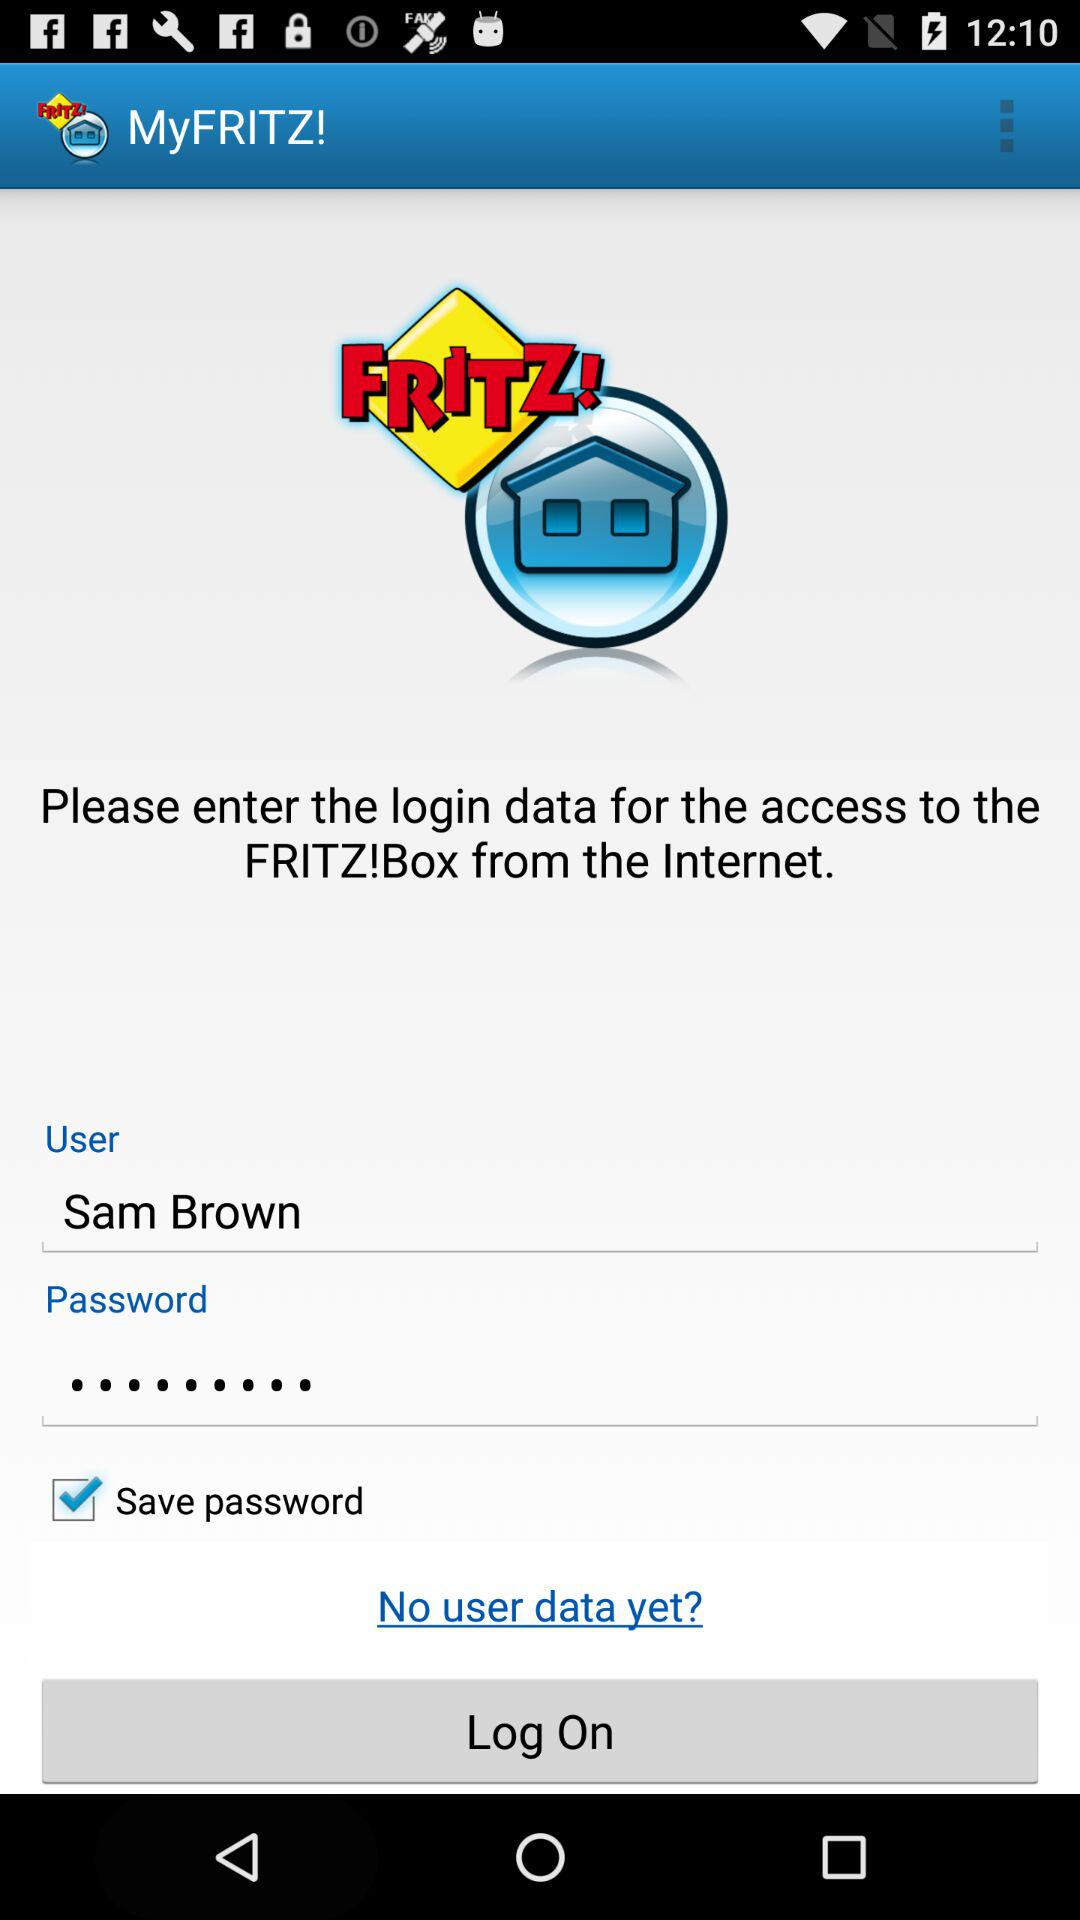What's the user name? The user name is Sam Brown. 